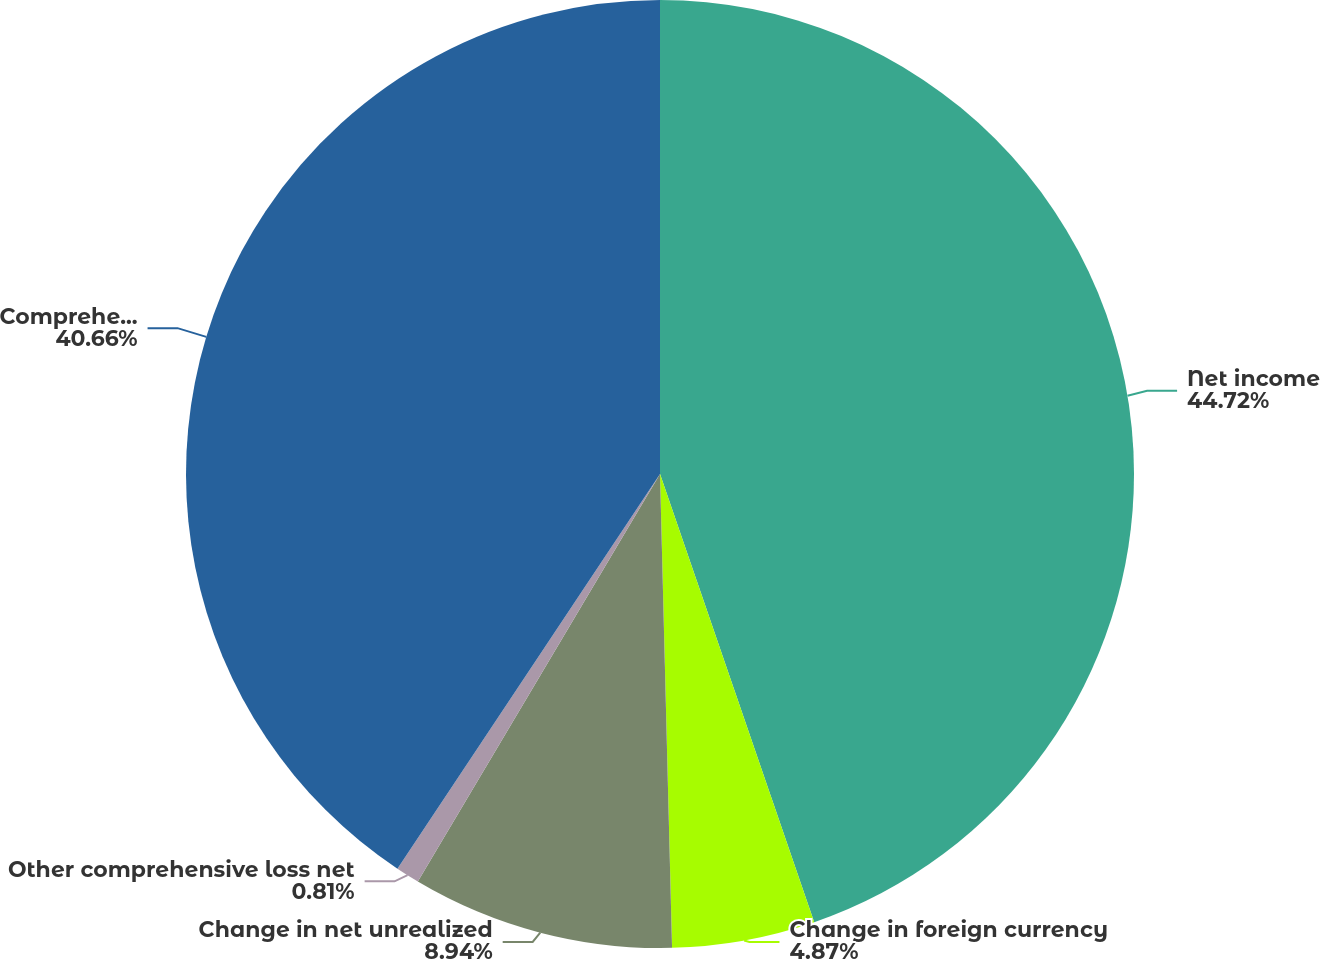Convert chart to OTSL. <chart><loc_0><loc_0><loc_500><loc_500><pie_chart><fcel>Net income<fcel>Change in foreign currency<fcel>Change in net unrealized<fcel>Other comprehensive loss net<fcel>Comprehensive income<nl><fcel>44.73%<fcel>4.87%<fcel>8.94%<fcel>0.81%<fcel>40.66%<nl></chart> 